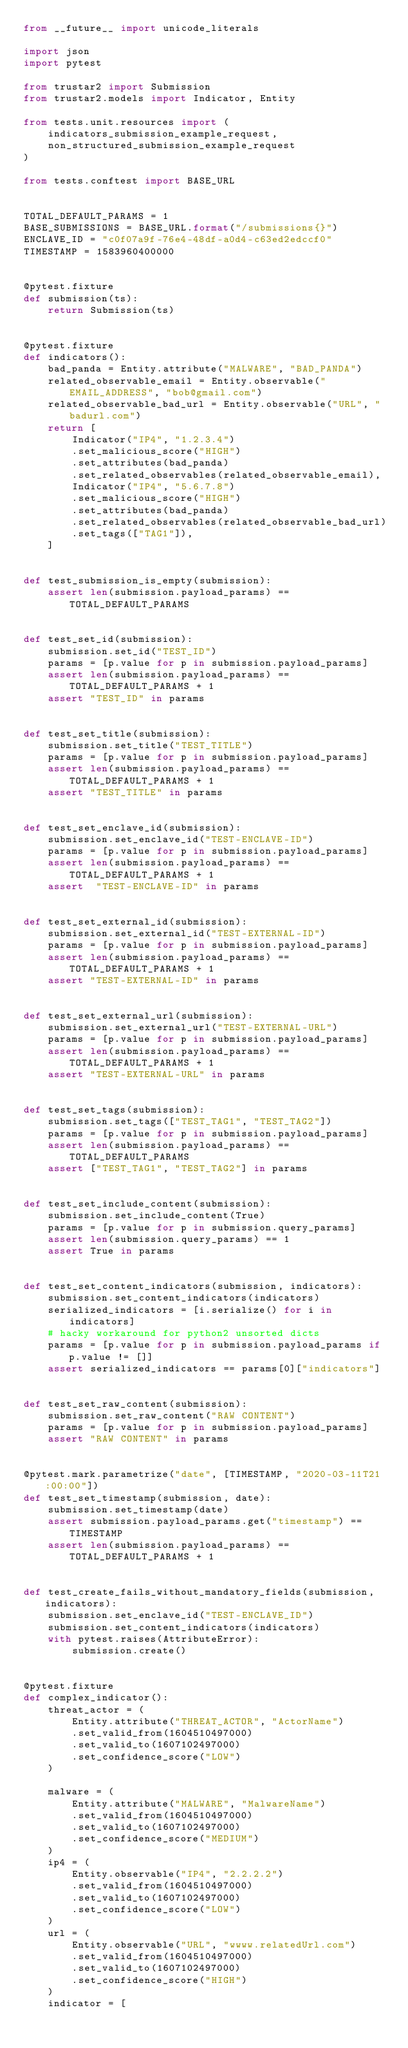Convert code to text. <code><loc_0><loc_0><loc_500><loc_500><_Python_>from __future__ import unicode_literals

import json
import pytest

from trustar2 import Submission
from trustar2.models import Indicator, Entity

from tests.unit.resources import (
    indicators_submission_example_request, 
    non_structured_submission_example_request
)

from tests.conftest import BASE_URL


TOTAL_DEFAULT_PARAMS = 1
BASE_SUBMISSIONS = BASE_URL.format("/submissions{}")
ENCLAVE_ID = "c0f07a9f-76e4-48df-a0d4-c63ed2edccf0"
TIMESTAMP = 1583960400000


@pytest.fixture
def submission(ts):
    return Submission(ts)


@pytest.fixture
def indicators():
    bad_panda = Entity.attribute("MALWARE", "BAD_PANDA")
    related_observable_email = Entity.observable("EMAIL_ADDRESS", "bob@gmail.com")
    related_observable_bad_url = Entity.observable("URL", "badurl.com")
    return [
        Indicator("IP4", "1.2.3.4")
        .set_malicious_score("HIGH")
        .set_attributes(bad_panda)
        .set_related_observables(related_observable_email),
        Indicator("IP4", "5.6.7.8")
        .set_malicious_score("HIGH")
        .set_attributes(bad_panda)
        .set_related_observables(related_observable_bad_url)
        .set_tags(["TAG1"]),
    ]


def test_submission_is_empty(submission):
    assert len(submission.payload_params) == TOTAL_DEFAULT_PARAMS


def test_set_id(submission):
    submission.set_id("TEST_ID")
    params = [p.value for p in submission.payload_params]
    assert len(submission.payload_params) == TOTAL_DEFAULT_PARAMS + 1
    assert "TEST_ID" in params


def test_set_title(submission):
    submission.set_title("TEST_TITLE")
    params = [p.value for p in submission.payload_params]
    assert len(submission.payload_params) == TOTAL_DEFAULT_PARAMS + 1
    assert "TEST_TITLE" in params


def test_set_enclave_id(submission):
    submission.set_enclave_id("TEST-ENCLAVE-ID")
    params = [p.value for p in submission.payload_params]
    assert len(submission.payload_params) == TOTAL_DEFAULT_PARAMS + 1
    assert  "TEST-ENCLAVE-ID" in params


def test_set_external_id(submission):
    submission.set_external_id("TEST-EXTERNAL-ID")
    params = [p.value for p in submission.payload_params]
    assert len(submission.payload_params) == TOTAL_DEFAULT_PARAMS + 1
    assert "TEST-EXTERNAL-ID" in params


def test_set_external_url(submission):
    submission.set_external_url("TEST-EXTERNAL-URL")
    params = [p.value for p in submission.payload_params]
    assert len(submission.payload_params) == TOTAL_DEFAULT_PARAMS + 1
    assert "TEST-EXTERNAL-URL" in params


def test_set_tags(submission):
    submission.set_tags(["TEST_TAG1", "TEST_TAG2"])
    params = [p.value for p in submission.payload_params]
    assert len(submission.payload_params) == TOTAL_DEFAULT_PARAMS
    assert ["TEST_TAG1", "TEST_TAG2"] in params


def test_set_include_content(submission):
    submission.set_include_content(True)
    params = [p.value for p in submission.query_params]
    assert len(submission.query_params) == 1
    assert True in params


def test_set_content_indicators(submission, indicators):
    submission.set_content_indicators(indicators)
    serialized_indicators = [i.serialize() for i in indicators]
    # hacky workaround for python2 unsorted dicts
    params = [p.value for p in submission.payload_params if p.value != []]
    assert serialized_indicators == params[0]["indicators"]


def test_set_raw_content(submission):
    submission.set_raw_content("RAW CONTENT")
    params = [p.value for p in submission.payload_params]
    assert "RAW CONTENT" in params


@pytest.mark.parametrize("date", [TIMESTAMP, "2020-03-11T21:00:00"])
def test_set_timestamp(submission, date):
    submission.set_timestamp(date)
    assert submission.payload_params.get("timestamp") == TIMESTAMP
    assert len(submission.payload_params) == TOTAL_DEFAULT_PARAMS + 1


def test_create_fails_without_mandatory_fields(submission, indicators):
    submission.set_enclave_id("TEST-ENCLAVE_ID")
    submission.set_content_indicators(indicators)
    with pytest.raises(AttributeError):
        submission.create()


@pytest.fixture
def complex_indicator():
    threat_actor = (
        Entity.attribute("THREAT_ACTOR", "ActorName")
        .set_valid_from(1604510497000)
        .set_valid_to(1607102497000)
        .set_confidence_score("LOW")
    )

    malware = (
        Entity.attribute("MALWARE", "MalwareName")
        .set_valid_from(1604510497000)
        .set_valid_to(1607102497000)
        .set_confidence_score("MEDIUM")
    )
    ip4 = (
        Entity.observable("IP4", "2.2.2.2")
        .set_valid_from(1604510497000)
        .set_valid_to(1607102497000)
        .set_confidence_score("LOW")
    )
    url = (
        Entity.observable("URL", "wwww.relatedUrl.com")
        .set_valid_from(1604510497000)
        .set_valid_to(1607102497000)
        .set_confidence_score("HIGH")
    )
    indicator = [</code> 